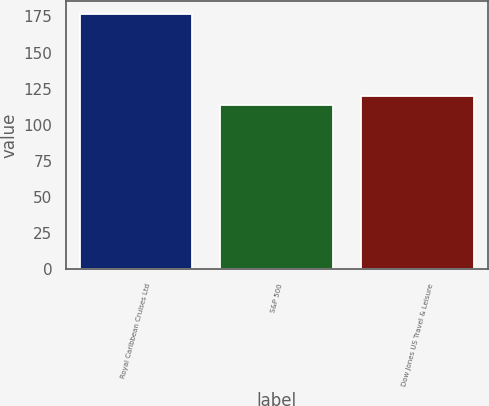Convert chart to OTSL. <chart><loc_0><loc_0><loc_500><loc_500><bar_chart><fcel>Royal Caribbean Cruises Ltd<fcel>S&P 500<fcel>Dow Jones US Travel & Leisure<nl><fcel>176.94<fcel>113.69<fcel>120.02<nl></chart> 